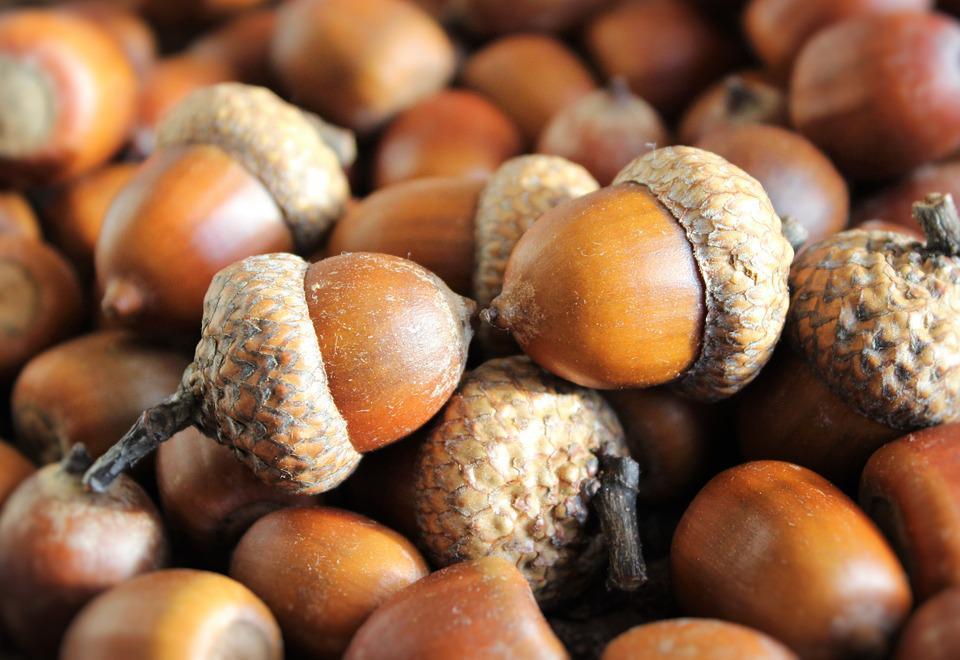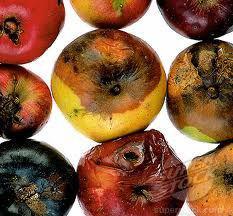The first image is the image on the left, the second image is the image on the right. For the images displayed, is the sentence "The left image includes at least one large green acorn with its cap on next to smaller brown acorns." factually correct? Answer yes or no. No. The first image is the image on the left, the second image is the image on the right. Evaluate the accuracy of this statement regarding the images: "There are brown and green acorns.". Is it true? Answer yes or no. No. 